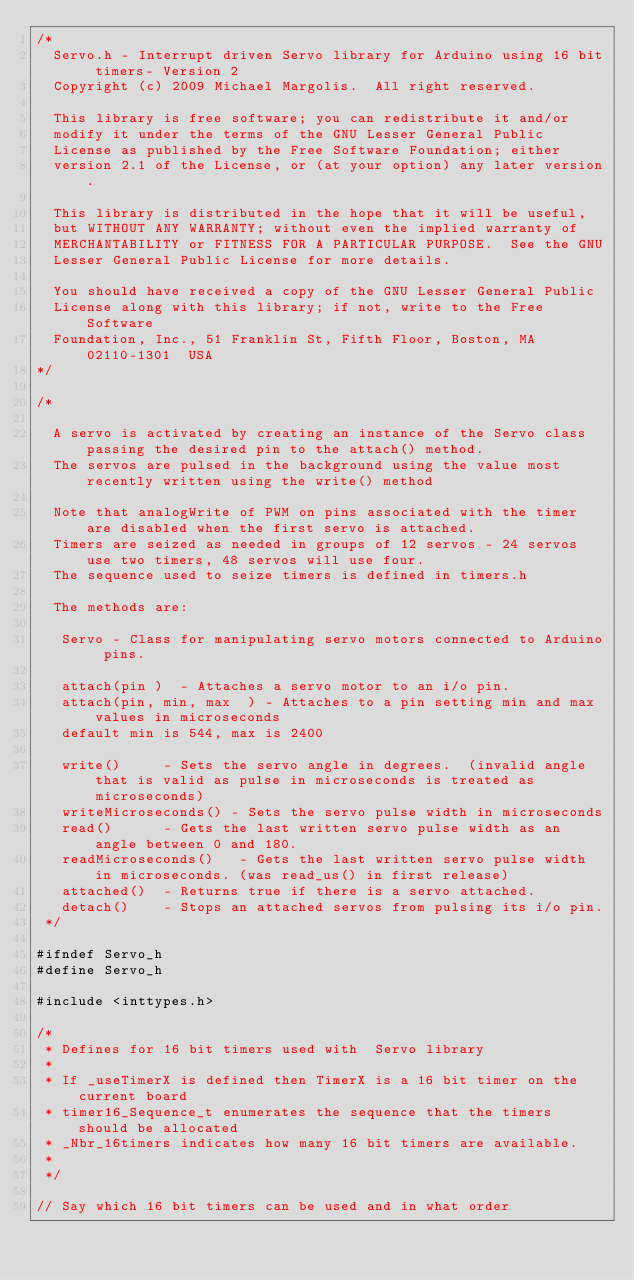Convert code to text. <code><loc_0><loc_0><loc_500><loc_500><_C_>/*
  Servo.h - Interrupt driven Servo library for Arduino using 16 bit timers- Version 2
  Copyright (c) 2009 Michael Margolis.  All right reserved.

  This library is free software; you can redistribute it and/or
  modify it under the terms of the GNU Lesser General Public
  License as published by the Free Software Foundation; either
  version 2.1 of the License, or (at your option) any later version.

  This library is distributed in the hope that it will be useful,
  but WITHOUT ANY WARRANTY; without even the implied warranty of
  MERCHANTABILITY or FITNESS FOR A PARTICULAR PURPOSE.  See the GNU
  Lesser General Public License for more details.

  You should have received a copy of the GNU Lesser General Public
  License along with this library; if not, write to the Free Software
  Foundation, Inc., 51 Franklin St, Fifth Floor, Boston, MA  02110-1301  USA
*/

/*

  A servo is activated by creating an instance of the Servo class passing the desired pin to the attach() method.
  The servos are pulsed in the background using the value most recently written using the write() method

  Note that analogWrite of PWM on pins associated with the timer are disabled when the first servo is attached.
  Timers are seized as needed in groups of 12 servos - 24 servos use two timers, 48 servos will use four.
  The sequence used to seize timers is defined in timers.h

  The methods are:

   Servo - Class for manipulating servo motors connected to Arduino pins.

   attach(pin )  - Attaches a servo motor to an i/o pin.
   attach(pin, min, max  ) - Attaches to a pin setting min and max values in microseconds
   default min is 544, max is 2400

   write()     - Sets the servo angle in degrees.  (invalid angle that is valid as pulse in microseconds is treated as microseconds)
   writeMicroseconds() - Sets the servo pulse width in microseconds
   read()      - Gets the last written servo pulse width as an angle between 0 and 180.
   readMicroseconds()   - Gets the last written servo pulse width in microseconds. (was read_us() in first release)
   attached()  - Returns true if there is a servo attached.
   detach()    - Stops an attached servos from pulsing its i/o pin.
 */

#ifndef Servo_h
#define Servo_h

#include <inttypes.h>

/*
 * Defines for 16 bit timers used with  Servo library
 *
 * If _useTimerX is defined then TimerX is a 16 bit timer on the current board
 * timer16_Sequence_t enumerates the sequence that the timers should be allocated
 * _Nbr_16timers indicates how many 16 bit timers are available.
 *
 */

// Say which 16 bit timers can be used and in what order</code> 